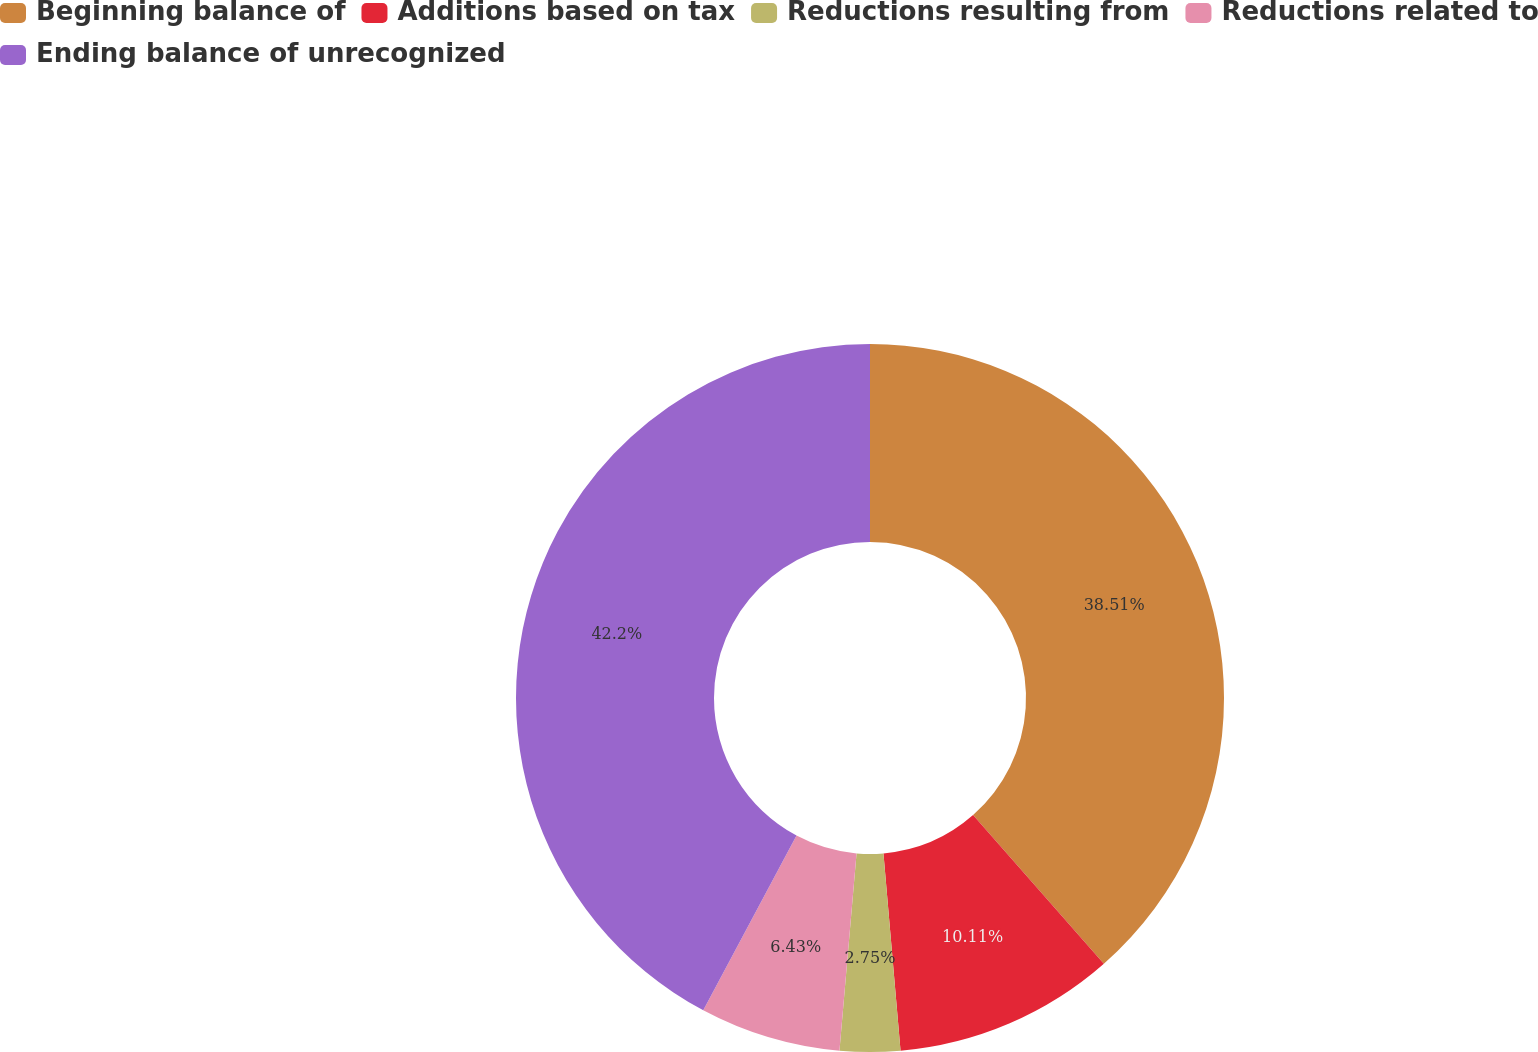Convert chart. <chart><loc_0><loc_0><loc_500><loc_500><pie_chart><fcel>Beginning balance of<fcel>Additions based on tax<fcel>Reductions resulting from<fcel>Reductions related to<fcel>Ending balance of unrecognized<nl><fcel>38.51%<fcel>10.11%<fcel>2.75%<fcel>6.43%<fcel>42.19%<nl></chart> 